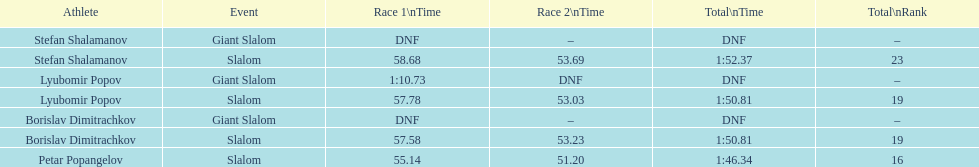How many athletes are there total? 4. 